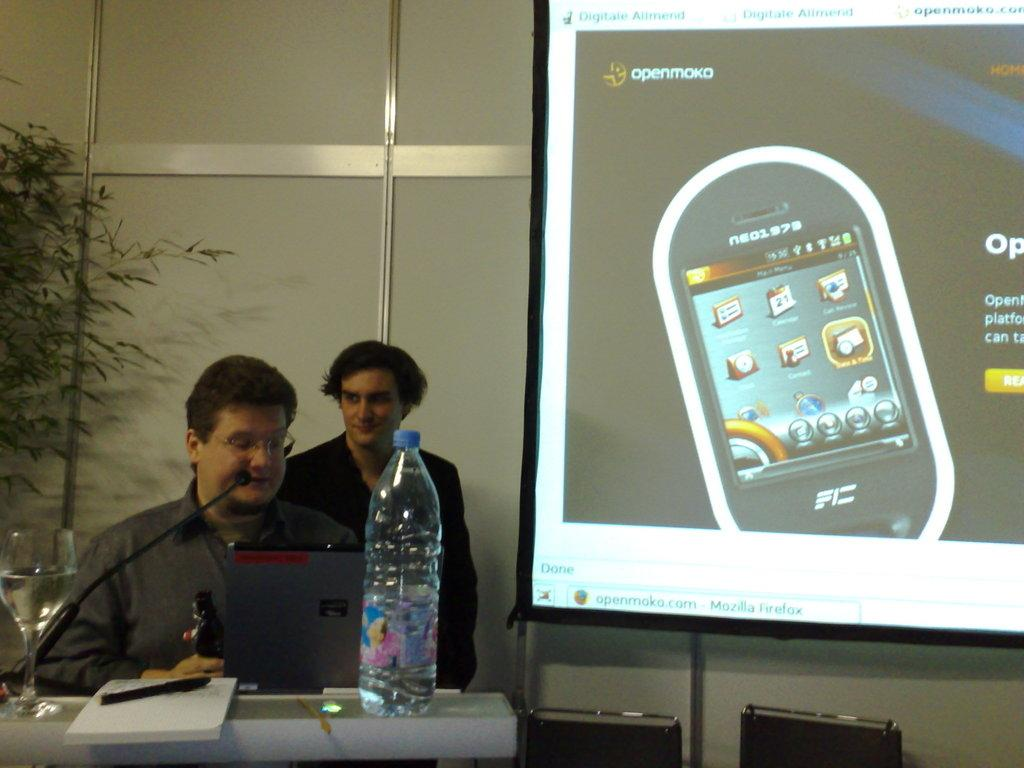What type of plant is visible in the image? There is a plant in the image, but the specific type cannot be determined from the provided facts. What can be seen on the screen in the image? The content on the screen cannot be determined from the provided facts. How many people are in the image? There are two people in the image. What is the purpose of the table in the image? The table is likely used for holding various items, such as the pen, book, glass, and bottle. What is the pen used for in the image? The pen might be used for writing or drawing, but its specific use cannot be determined from the provided facts. What is the book about in the image? The content of the book cannot be determined from the provided facts. What is the glass used for in the image? The glass might be used for holding a beverage, but its specific use cannot be determined from the provided facts. What is the bottle used for in the image? The bottle might be used for holding a liquid, but its specific use cannot be determined from the provided facts. How many babies are crawling on the table in the image? There are no babies present in the image; it only features a plant, a screen, two people, a table, a pen, a book, a glass, and a bottle. What type of drum is visible on the screen in the image? There is no drum visible on the screen in the image; the content on the screen cannot be determined from the provided facts. 